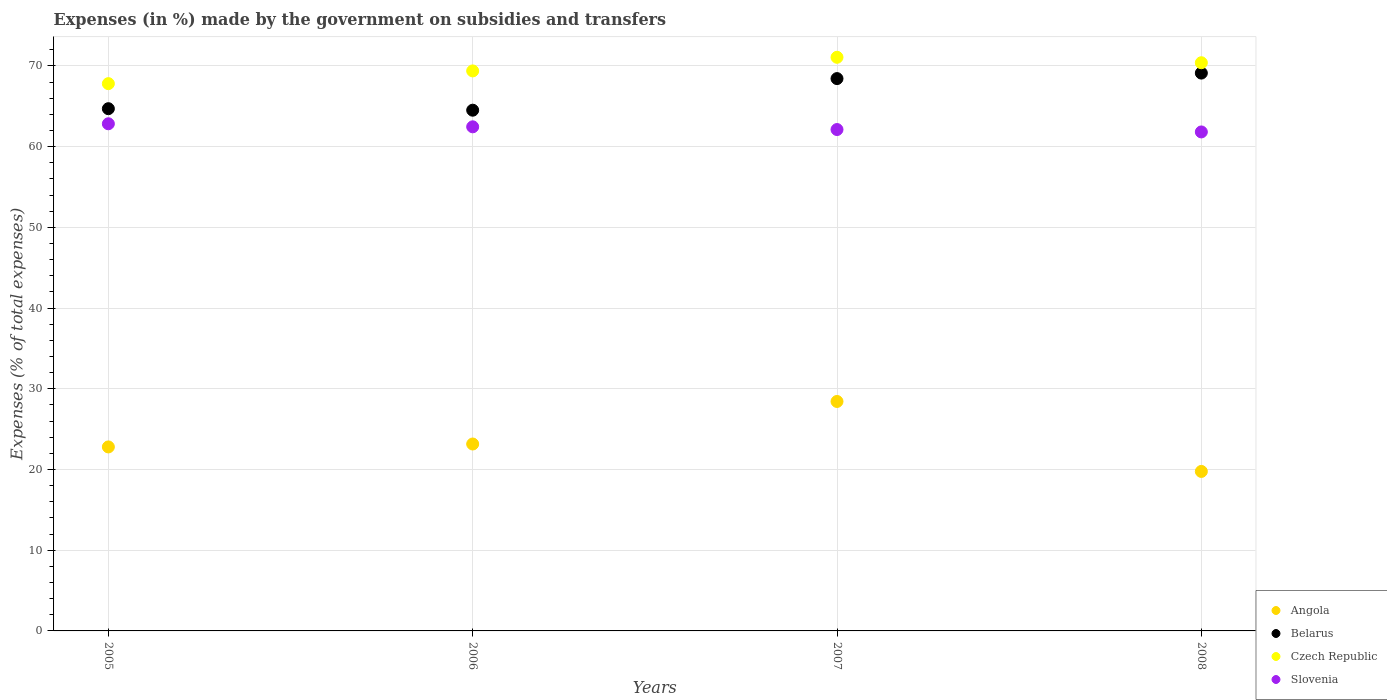Is the number of dotlines equal to the number of legend labels?
Offer a very short reply. Yes. What is the percentage of expenses made by the government on subsidies and transfers in Slovenia in 2005?
Ensure brevity in your answer.  62.84. Across all years, what is the maximum percentage of expenses made by the government on subsidies and transfers in Czech Republic?
Give a very brief answer. 71.08. Across all years, what is the minimum percentage of expenses made by the government on subsidies and transfers in Angola?
Keep it short and to the point. 19.76. What is the total percentage of expenses made by the government on subsidies and transfers in Czech Republic in the graph?
Provide a short and direct response. 278.69. What is the difference between the percentage of expenses made by the government on subsidies and transfers in Slovenia in 2007 and that in 2008?
Give a very brief answer. 0.3. What is the difference between the percentage of expenses made by the government on subsidies and transfers in Slovenia in 2005 and the percentage of expenses made by the government on subsidies and transfers in Belarus in 2007?
Your answer should be very brief. -5.6. What is the average percentage of expenses made by the government on subsidies and transfers in Slovenia per year?
Your response must be concise. 62.31. In the year 2005, what is the difference between the percentage of expenses made by the government on subsidies and transfers in Belarus and percentage of expenses made by the government on subsidies and transfers in Czech Republic?
Your answer should be very brief. -3.1. In how many years, is the percentage of expenses made by the government on subsidies and transfers in Slovenia greater than 40 %?
Provide a succinct answer. 4. What is the ratio of the percentage of expenses made by the government on subsidies and transfers in Belarus in 2006 to that in 2007?
Provide a succinct answer. 0.94. Is the percentage of expenses made by the government on subsidies and transfers in Czech Republic in 2006 less than that in 2008?
Ensure brevity in your answer.  Yes. Is the difference between the percentage of expenses made by the government on subsidies and transfers in Belarus in 2006 and 2007 greater than the difference between the percentage of expenses made by the government on subsidies and transfers in Czech Republic in 2006 and 2007?
Provide a succinct answer. No. What is the difference between the highest and the second highest percentage of expenses made by the government on subsidies and transfers in Slovenia?
Your response must be concise. 0.38. What is the difference between the highest and the lowest percentage of expenses made by the government on subsidies and transfers in Belarus?
Give a very brief answer. 4.6. In how many years, is the percentage of expenses made by the government on subsidies and transfers in Angola greater than the average percentage of expenses made by the government on subsidies and transfers in Angola taken over all years?
Ensure brevity in your answer.  1. Is the sum of the percentage of expenses made by the government on subsidies and transfers in Angola in 2006 and 2008 greater than the maximum percentage of expenses made by the government on subsidies and transfers in Belarus across all years?
Your answer should be very brief. No. Is it the case that in every year, the sum of the percentage of expenses made by the government on subsidies and transfers in Czech Republic and percentage of expenses made by the government on subsidies and transfers in Belarus  is greater than the sum of percentage of expenses made by the government on subsidies and transfers in Slovenia and percentage of expenses made by the government on subsidies and transfers in Angola?
Offer a terse response. No. Is it the case that in every year, the sum of the percentage of expenses made by the government on subsidies and transfers in Angola and percentage of expenses made by the government on subsidies and transfers in Czech Republic  is greater than the percentage of expenses made by the government on subsidies and transfers in Slovenia?
Provide a short and direct response. Yes. Does the percentage of expenses made by the government on subsidies and transfers in Belarus monotonically increase over the years?
Your response must be concise. No. Is the percentage of expenses made by the government on subsidies and transfers in Belarus strictly greater than the percentage of expenses made by the government on subsidies and transfers in Czech Republic over the years?
Offer a terse response. No. What is the difference between two consecutive major ticks on the Y-axis?
Your answer should be compact. 10. Does the graph contain grids?
Give a very brief answer. Yes. How many legend labels are there?
Provide a short and direct response. 4. What is the title of the graph?
Offer a very short reply. Expenses (in %) made by the government on subsidies and transfers. Does "Faeroe Islands" appear as one of the legend labels in the graph?
Make the answer very short. No. What is the label or title of the Y-axis?
Offer a very short reply. Expenses (% of total expenses). What is the Expenses (% of total expenses) in Angola in 2005?
Ensure brevity in your answer.  22.8. What is the Expenses (% of total expenses) in Belarus in 2005?
Your answer should be compact. 64.71. What is the Expenses (% of total expenses) in Czech Republic in 2005?
Ensure brevity in your answer.  67.81. What is the Expenses (% of total expenses) in Slovenia in 2005?
Provide a short and direct response. 62.84. What is the Expenses (% of total expenses) of Angola in 2006?
Make the answer very short. 23.16. What is the Expenses (% of total expenses) in Belarus in 2006?
Offer a terse response. 64.52. What is the Expenses (% of total expenses) in Czech Republic in 2006?
Your response must be concise. 69.39. What is the Expenses (% of total expenses) in Slovenia in 2006?
Provide a short and direct response. 62.46. What is the Expenses (% of total expenses) in Angola in 2007?
Give a very brief answer. 28.43. What is the Expenses (% of total expenses) of Belarus in 2007?
Offer a terse response. 68.44. What is the Expenses (% of total expenses) of Czech Republic in 2007?
Your answer should be compact. 71.08. What is the Expenses (% of total expenses) in Slovenia in 2007?
Ensure brevity in your answer.  62.13. What is the Expenses (% of total expenses) of Angola in 2008?
Your answer should be very brief. 19.76. What is the Expenses (% of total expenses) in Belarus in 2008?
Make the answer very short. 69.12. What is the Expenses (% of total expenses) in Czech Republic in 2008?
Make the answer very short. 70.4. What is the Expenses (% of total expenses) in Slovenia in 2008?
Your response must be concise. 61.83. Across all years, what is the maximum Expenses (% of total expenses) of Angola?
Your answer should be compact. 28.43. Across all years, what is the maximum Expenses (% of total expenses) of Belarus?
Your answer should be very brief. 69.12. Across all years, what is the maximum Expenses (% of total expenses) in Czech Republic?
Provide a succinct answer. 71.08. Across all years, what is the maximum Expenses (% of total expenses) in Slovenia?
Keep it short and to the point. 62.84. Across all years, what is the minimum Expenses (% of total expenses) of Angola?
Offer a terse response. 19.76. Across all years, what is the minimum Expenses (% of total expenses) of Belarus?
Your response must be concise. 64.52. Across all years, what is the minimum Expenses (% of total expenses) in Czech Republic?
Your answer should be compact. 67.81. Across all years, what is the minimum Expenses (% of total expenses) of Slovenia?
Offer a very short reply. 61.83. What is the total Expenses (% of total expenses) of Angola in the graph?
Your answer should be compact. 94.15. What is the total Expenses (% of total expenses) of Belarus in the graph?
Make the answer very short. 266.79. What is the total Expenses (% of total expenses) in Czech Republic in the graph?
Give a very brief answer. 278.69. What is the total Expenses (% of total expenses) of Slovenia in the graph?
Offer a terse response. 249.26. What is the difference between the Expenses (% of total expenses) of Angola in 2005 and that in 2006?
Provide a short and direct response. -0.36. What is the difference between the Expenses (% of total expenses) in Belarus in 2005 and that in 2006?
Your response must be concise. 0.19. What is the difference between the Expenses (% of total expenses) of Czech Republic in 2005 and that in 2006?
Ensure brevity in your answer.  -1.58. What is the difference between the Expenses (% of total expenses) in Slovenia in 2005 and that in 2006?
Provide a succinct answer. 0.38. What is the difference between the Expenses (% of total expenses) of Angola in 2005 and that in 2007?
Your response must be concise. -5.63. What is the difference between the Expenses (% of total expenses) in Belarus in 2005 and that in 2007?
Your answer should be compact. -3.73. What is the difference between the Expenses (% of total expenses) of Czech Republic in 2005 and that in 2007?
Provide a succinct answer. -3.27. What is the difference between the Expenses (% of total expenses) in Slovenia in 2005 and that in 2007?
Your response must be concise. 0.71. What is the difference between the Expenses (% of total expenses) of Angola in 2005 and that in 2008?
Offer a terse response. 3.04. What is the difference between the Expenses (% of total expenses) of Belarus in 2005 and that in 2008?
Give a very brief answer. -4.41. What is the difference between the Expenses (% of total expenses) of Czech Republic in 2005 and that in 2008?
Keep it short and to the point. -2.59. What is the difference between the Expenses (% of total expenses) in Slovenia in 2005 and that in 2008?
Provide a short and direct response. 1.01. What is the difference between the Expenses (% of total expenses) of Angola in 2006 and that in 2007?
Give a very brief answer. -5.27. What is the difference between the Expenses (% of total expenses) of Belarus in 2006 and that in 2007?
Your answer should be very brief. -3.92. What is the difference between the Expenses (% of total expenses) of Czech Republic in 2006 and that in 2007?
Your answer should be very brief. -1.69. What is the difference between the Expenses (% of total expenses) in Slovenia in 2006 and that in 2007?
Your answer should be compact. 0.34. What is the difference between the Expenses (% of total expenses) in Angola in 2006 and that in 2008?
Offer a very short reply. 3.4. What is the difference between the Expenses (% of total expenses) of Belarus in 2006 and that in 2008?
Your answer should be very brief. -4.6. What is the difference between the Expenses (% of total expenses) of Czech Republic in 2006 and that in 2008?
Make the answer very short. -1.01. What is the difference between the Expenses (% of total expenses) in Slovenia in 2006 and that in 2008?
Provide a short and direct response. 0.63. What is the difference between the Expenses (% of total expenses) of Angola in 2007 and that in 2008?
Your response must be concise. 8.67. What is the difference between the Expenses (% of total expenses) in Belarus in 2007 and that in 2008?
Make the answer very short. -0.68. What is the difference between the Expenses (% of total expenses) in Czech Republic in 2007 and that in 2008?
Your response must be concise. 0.68. What is the difference between the Expenses (% of total expenses) in Slovenia in 2007 and that in 2008?
Give a very brief answer. 0.3. What is the difference between the Expenses (% of total expenses) of Angola in 2005 and the Expenses (% of total expenses) of Belarus in 2006?
Offer a very short reply. -41.72. What is the difference between the Expenses (% of total expenses) of Angola in 2005 and the Expenses (% of total expenses) of Czech Republic in 2006?
Give a very brief answer. -46.59. What is the difference between the Expenses (% of total expenses) in Angola in 2005 and the Expenses (% of total expenses) in Slovenia in 2006?
Ensure brevity in your answer.  -39.66. What is the difference between the Expenses (% of total expenses) of Belarus in 2005 and the Expenses (% of total expenses) of Czech Republic in 2006?
Ensure brevity in your answer.  -4.68. What is the difference between the Expenses (% of total expenses) of Belarus in 2005 and the Expenses (% of total expenses) of Slovenia in 2006?
Give a very brief answer. 2.25. What is the difference between the Expenses (% of total expenses) in Czech Republic in 2005 and the Expenses (% of total expenses) in Slovenia in 2006?
Offer a terse response. 5.35. What is the difference between the Expenses (% of total expenses) in Angola in 2005 and the Expenses (% of total expenses) in Belarus in 2007?
Make the answer very short. -45.64. What is the difference between the Expenses (% of total expenses) of Angola in 2005 and the Expenses (% of total expenses) of Czech Republic in 2007?
Give a very brief answer. -48.28. What is the difference between the Expenses (% of total expenses) of Angola in 2005 and the Expenses (% of total expenses) of Slovenia in 2007?
Provide a short and direct response. -39.33. What is the difference between the Expenses (% of total expenses) in Belarus in 2005 and the Expenses (% of total expenses) in Czech Republic in 2007?
Make the answer very short. -6.37. What is the difference between the Expenses (% of total expenses) in Belarus in 2005 and the Expenses (% of total expenses) in Slovenia in 2007?
Ensure brevity in your answer.  2.58. What is the difference between the Expenses (% of total expenses) of Czech Republic in 2005 and the Expenses (% of total expenses) of Slovenia in 2007?
Provide a succinct answer. 5.69. What is the difference between the Expenses (% of total expenses) in Angola in 2005 and the Expenses (% of total expenses) in Belarus in 2008?
Offer a very short reply. -46.32. What is the difference between the Expenses (% of total expenses) in Angola in 2005 and the Expenses (% of total expenses) in Czech Republic in 2008?
Offer a terse response. -47.6. What is the difference between the Expenses (% of total expenses) in Angola in 2005 and the Expenses (% of total expenses) in Slovenia in 2008?
Provide a succinct answer. -39.03. What is the difference between the Expenses (% of total expenses) in Belarus in 2005 and the Expenses (% of total expenses) in Czech Republic in 2008?
Offer a very short reply. -5.69. What is the difference between the Expenses (% of total expenses) in Belarus in 2005 and the Expenses (% of total expenses) in Slovenia in 2008?
Offer a very short reply. 2.88. What is the difference between the Expenses (% of total expenses) of Czech Republic in 2005 and the Expenses (% of total expenses) of Slovenia in 2008?
Offer a very short reply. 5.98. What is the difference between the Expenses (% of total expenses) of Angola in 2006 and the Expenses (% of total expenses) of Belarus in 2007?
Ensure brevity in your answer.  -45.28. What is the difference between the Expenses (% of total expenses) in Angola in 2006 and the Expenses (% of total expenses) in Czech Republic in 2007?
Offer a very short reply. -47.92. What is the difference between the Expenses (% of total expenses) in Angola in 2006 and the Expenses (% of total expenses) in Slovenia in 2007?
Make the answer very short. -38.97. What is the difference between the Expenses (% of total expenses) in Belarus in 2006 and the Expenses (% of total expenses) in Czech Republic in 2007?
Your answer should be compact. -6.56. What is the difference between the Expenses (% of total expenses) in Belarus in 2006 and the Expenses (% of total expenses) in Slovenia in 2007?
Your answer should be very brief. 2.4. What is the difference between the Expenses (% of total expenses) of Czech Republic in 2006 and the Expenses (% of total expenses) of Slovenia in 2007?
Make the answer very short. 7.26. What is the difference between the Expenses (% of total expenses) in Angola in 2006 and the Expenses (% of total expenses) in Belarus in 2008?
Make the answer very short. -45.96. What is the difference between the Expenses (% of total expenses) in Angola in 2006 and the Expenses (% of total expenses) in Czech Republic in 2008?
Keep it short and to the point. -47.24. What is the difference between the Expenses (% of total expenses) in Angola in 2006 and the Expenses (% of total expenses) in Slovenia in 2008?
Your answer should be compact. -38.67. What is the difference between the Expenses (% of total expenses) in Belarus in 2006 and the Expenses (% of total expenses) in Czech Republic in 2008?
Provide a short and direct response. -5.88. What is the difference between the Expenses (% of total expenses) of Belarus in 2006 and the Expenses (% of total expenses) of Slovenia in 2008?
Provide a succinct answer. 2.69. What is the difference between the Expenses (% of total expenses) in Czech Republic in 2006 and the Expenses (% of total expenses) in Slovenia in 2008?
Provide a short and direct response. 7.56. What is the difference between the Expenses (% of total expenses) of Angola in 2007 and the Expenses (% of total expenses) of Belarus in 2008?
Give a very brief answer. -40.69. What is the difference between the Expenses (% of total expenses) in Angola in 2007 and the Expenses (% of total expenses) in Czech Republic in 2008?
Make the answer very short. -41.97. What is the difference between the Expenses (% of total expenses) of Angola in 2007 and the Expenses (% of total expenses) of Slovenia in 2008?
Offer a very short reply. -33.4. What is the difference between the Expenses (% of total expenses) in Belarus in 2007 and the Expenses (% of total expenses) in Czech Republic in 2008?
Your answer should be compact. -1.96. What is the difference between the Expenses (% of total expenses) of Belarus in 2007 and the Expenses (% of total expenses) of Slovenia in 2008?
Your answer should be very brief. 6.61. What is the difference between the Expenses (% of total expenses) in Czech Republic in 2007 and the Expenses (% of total expenses) in Slovenia in 2008?
Your answer should be compact. 9.25. What is the average Expenses (% of total expenses) in Angola per year?
Offer a terse response. 23.54. What is the average Expenses (% of total expenses) of Belarus per year?
Offer a terse response. 66.7. What is the average Expenses (% of total expenses) in Czech Republic per year?
Keep it short and to the point. 69.67. What is the average Expenses (% of total expenses) of Slovenia per year?
Offer a very short reply. 62.31. In the year 2005, what is the difference between the Expenses (% of total expenses) in Angola and Expenses (% of total expenses) in Belarus?
Your answer should be compact. -41.91. In the year 2005, what is the difference between the Expenses (% of total expenses) in Angola and Expenses (% of total expenses) in Czech Republic?
Provide a short and direct response. -45.01. In the year 2005, what is the difference between the Expenses (% of total expenses) of Angola and Expenses (% of total expenses) of Slovenia?
Provide a short and direct response. -40.04. In the year 2005, what is the difference between the Expenses (% of total expenses) in Belarus and Expenses (% of total expenses) in Czech Republic?
Keep it short and to the point. -3.1. In the year 2005, what is the difference between the Expenses (% of total expenses) of Belarus and Expenses (% of total expenses) of Slovenia?
Make the answer very short. 1.87. In the year 2005, what is the difference between the Expenses (% of total expenses) in Czech Republic and Expenses (% of total expenses) in Slovenia?
Provide a short and direct response. 4.97. In the year 2006, what is the difference between the Expenses (% of total expenses) in Angola and Expenses (% of total expenses) in Belarus?
Offer a very short reply. -41.36. In the year 2006, what is the difference between the Expenses (% of total expenses) of Angola and Expenses (% of total expenses) of Czech Republic?
Offer a terse response. -46.23. In the year 2006, what is the difference between the Expenses (% of total expenses) in Angola and Expenses (% of total expenses) in Slovenia?
Ensure brevity in your answer.  -39.3. In the year 2006, what is the difference between the Expenses (% of total expenses) of Belarus and Expenses (% of total expenses) of Czech Republic?
Your response must be concise. -4.87. In the year 2006, what is the difference between the Expenses (% of total expenses) of Belarus and Expenses (% of total expenses) of Slovenia?
Your response must be concise. 2.06. In the year 2006, what is the difference between the Expenses (% of total expenses) in Czech Republic and Expenses (% of total expenses) in Slovenia?
Provide a succinct answer. 6.93. In the year 2007, what is the difference between the Expenses (% of total expenses) of Angola and Expenses (% of total expenses) of Belarus?
Your response must be concise. -40.01. In the year 2007, what is the difference between the Expenses (% of total expenses) of Angola and Expenses (% of total expenses) of Czech Republic?
Keep it short and to the point. -42.65. In the year 2007, what is the difference between the Expenses (% of total expenses) of Angola and Expenses (% of total expenses) of Slovenia?
Your answer should be compact. -33.7. In the year 2007, what is the difference between the Expenses (% of total expenses) of Belarus and Expenses (% of total expenses) of Czech Republic?
Offer a very short reply. -2.64. In the year 2007, what is the difference between the Expenses (% of total expenses) of Belarus and Expenses (% of total expenses) of Slovenia?
Offer a terse response. 6.31. In the year 2007, what is the difference between the Expenses (% of total expenses) in Czech Republic and Expenses (% of total expenses) in Slovenia?
Your answer should be compact. 8.95. In the year 2008, what is the difference between the Expenses (% of total expenses) of Angola and Expenses (% of total expenses) of Belarus?
Your response must be concise. -49.36. In the year 2008, what is the difference between the Expenses (% of total expenses) of Angola and Expenses (% of total expenses) of Czech Republic?
Your answer should be compact. -50.64. In the year 2008, what is the difference between the Expenses (% of total expenses) of Angola and Expenses (% of total expenses) of Slovenia?
Keep it short and to the point. -42.07. In the year 2008, what is the difference between the Expenses (% of total expenses) of Belarus and Expenses (% of total expenses) of Czech Republic?
Your answer should be very brief. -1.28. In the year 2008, what is the difference between the Expenses (% of total expenses) of Belarus and Expenses (% of total expenses) of Slovenia?
Make the answer very short. 7.29. In the year 2008, what is the difference between the Expenses (% of total expenses) of Czech Republic and Expenses (% of total expenses) of Slovenia?
Your answer should be compact. 8.57. What is the ratio of the Expenses (% of total expenses) in Angola in 2005 to that in 2006?
Your answer should be compact. 0.98. What is the ratio of the Expenses (% of total expenses) in Belarus in 2005 to that in 2006?
Your answer should be compact. 1. What is the ratio of the Expenses (% of total expenses) of Czech Republic in 2005 to that in 2006?
Your answer should be very brief. 0.98. What is the ratio of the Expenses (% of total expenses) in Angola in 2005 to that in 2007?
Provide a short and direct response. 0.8. What is the ratio of the Expenses (% of total expenses) in Belarus in 2005 to that in 2007?
Give a very brief answer. 0.95. What is the ratio of the Expenses (% of total expenses) in Czech Republic in 2005 to that in 2007?
Provide a short and direct response. 0.95. What is the ratio of the Expenses (% of total expenses) in Slovenia in 2005 to that in 2007?
Offer a terse response. 1.01. What is the ratio of the Expenses (% of total expenses) of Angola in 2005 to that in 2008?
Your answer should be very brief. 1.15. What is the ratio of the Expenses (% of total expenses) in Belarus in 2005 to that in 2008?
Your answer should be very brief. 0.94. What is the ratio of the Expenses (% of total expenses) in Czech Republic in 2005 to that in 2008?
Make the answer very short. 0.96. What is the ratio of the Expenses (% of total expenses) of Slovenia in 2005 to that in 2008?
Your answer should be very brief. 1.02. What is the ratio of the Expenses (% of total expenses) of Angola in 2006 to that in 2007?
Your answer should be very brief. 0.81. What is the ratio of the Expenses (% of total expenses) of Belarus in 2006 to that in 2007?
Make the answer very short. 0.94. What is the ratio of the Expenses (% of total expenses) in Czech Republic in 2006 to that in 2007?
Offer a very short reply. 0.98. What is the ratio of the Expenses (% of total expenses) in Slovenia in 2006 to that in 2007?
Your response must be concise. 1.01. What is the ratio of the Expenses (% of total expenses) of Angola in 2006 to that in 2008?
Keep it short and to the point. 1.17. What is the ratio of the Expenses (% of total expenses) of Belarus in 2006 to that in 2008?
Provide a short and direct response. 0.93. What is the ratio of the Expenses (% of total expenses) in Czech Republic in 2006 to that in 2008?
Provide a succinct answer. 0.99. What is the ratio of the Expenses (% of total expenses) of Slovenia in 2006 to that in 2008?
Keep it short and to the point. 1.01. What is the ratio of the Expenses (% of total expenses) in Angola in 2007 to that in 2008?
Give a very brief answer. 1.44. What is the ratio of the Expenses (% of total expenses) in Belarus in 2007 to that in 2008?
Offer a very short reply. 0.99. What is the ratio of the Expenses (% of total expenses) of Czech Republic in 2007 to that in 2008?
Offer a terse response. 1.01. What is the ratio of the Expenses (% of total expenses) of Slovenia in 2007 to that in 2008?
Make the answer very short. 1. What is the difference between the highest and the second highest Expenses (% of total expenses) in Angola?
Give a very brief answer. 5.27. What is the difference between the highest and the second highest Expenses (% of total expenses) in Belarus?
Offer a terse response. 0.68. What is the difference between the highest and the second highest Expenses (% of total expenses) in Czech Republic?
Your answer should be compact. 0.68. What is the difference between the highest and the second highest Expenses (% of total expenses) of Slovenia?
Keep it short and to the point. 0.38. What is the difference between the highest and the lowest Expenses (% of total expenses) of Angola?
Ensure brevity in your answer.  8.67. What is the difference between the highest and the lowest Expenses (% of total expenses) in Belarus?
Ensure brevity in your answer.  4.6. What is the difference between the highest and the lowest Expenses (% of total expenses) of Czech Republic?
Your answer should be very brief. 3.27. What is the difference between the highest and the lowest Expenses (% of total expenses) of Slovenia?
Provide a succinct answer. 1.01. 